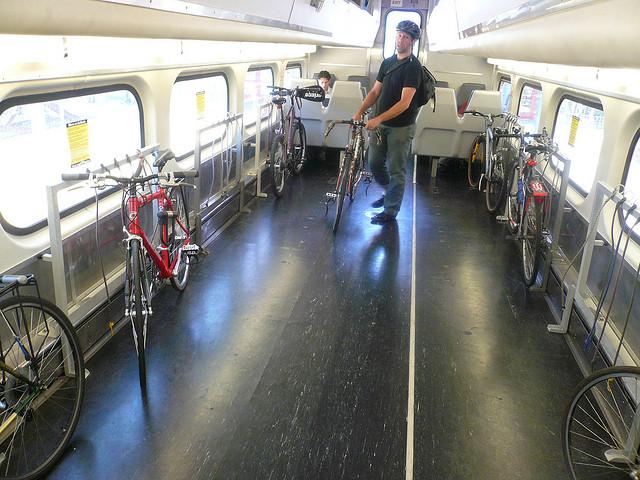How many bikes are there?
Be succinct. 7. How many people are in the picture?
Concise answer only. 2. Who is holding the bike?
Write a very short answer. Man. 